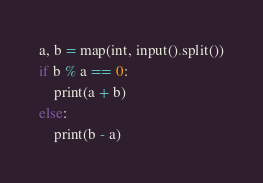Convert code to text. <code><loc_0><loc_0><loc_500><loc_500><_Python_>a, b = map(int, input().split())
if b % a == 0:
    print(a + b)
else:
    print(b - a)</code> 